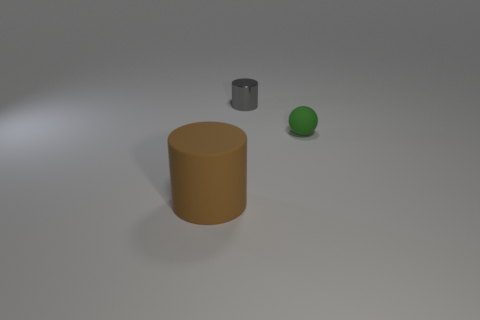Subtract all cylinders. How many objects are left? 1 Add 3 big blue metallic things. How many big blue metallic things exist? 3 Add 2 purple matte blocks. How many objects exist? 5 Subtract 0 yellow blocks. How many objects are left? 3 Subtract 1 spheres. How many spheres are left? 0 Subtract all brown cylinders. Subtract all green blocks. How many cylinders are left? 1 Subtract all gray spheres. How many green cylinders are left? 0 Subtract all big matte cylinders. Subtract all tiny green objects. How many objects are left? 1 Add 2 large rubber objects. How many large rubber objects are left? 3 